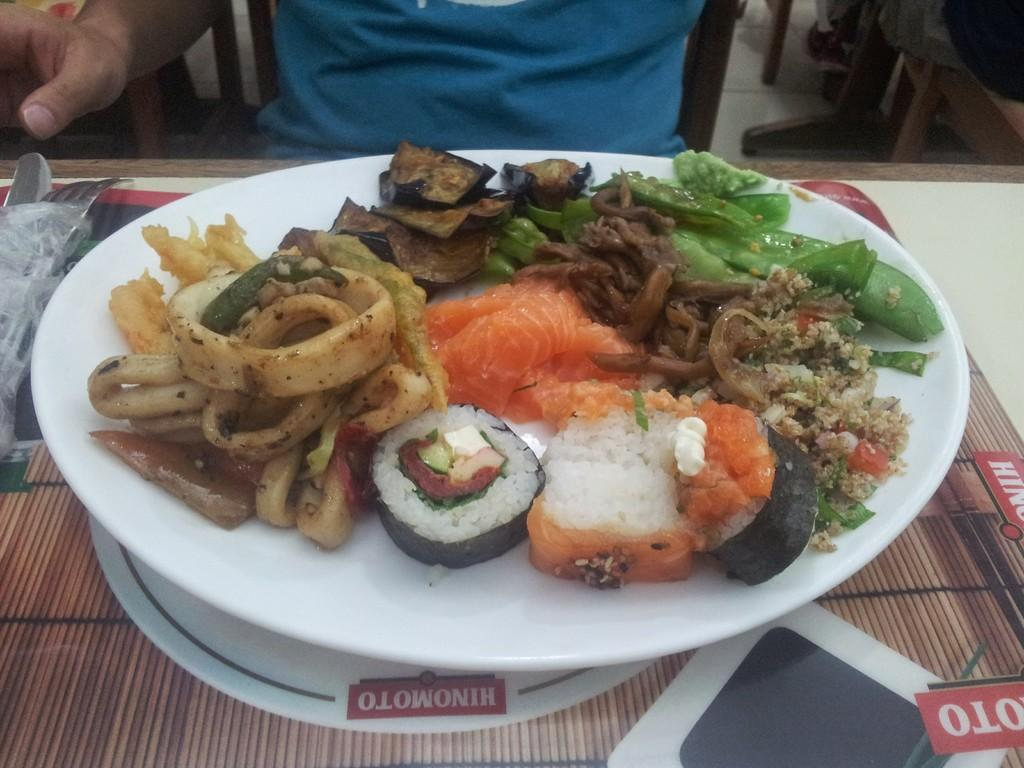What is the person in the image doing? The person is riding a bicycle on a road. What can be seen in the background of the image? There are trees and a road in the background of the image. What type of selection is available for the person to choose from in the image? There is no selection present in the image; it features a person riding a bicycle on a road. What date is marked on the calendar in the image? There is no calendar present in the image. 